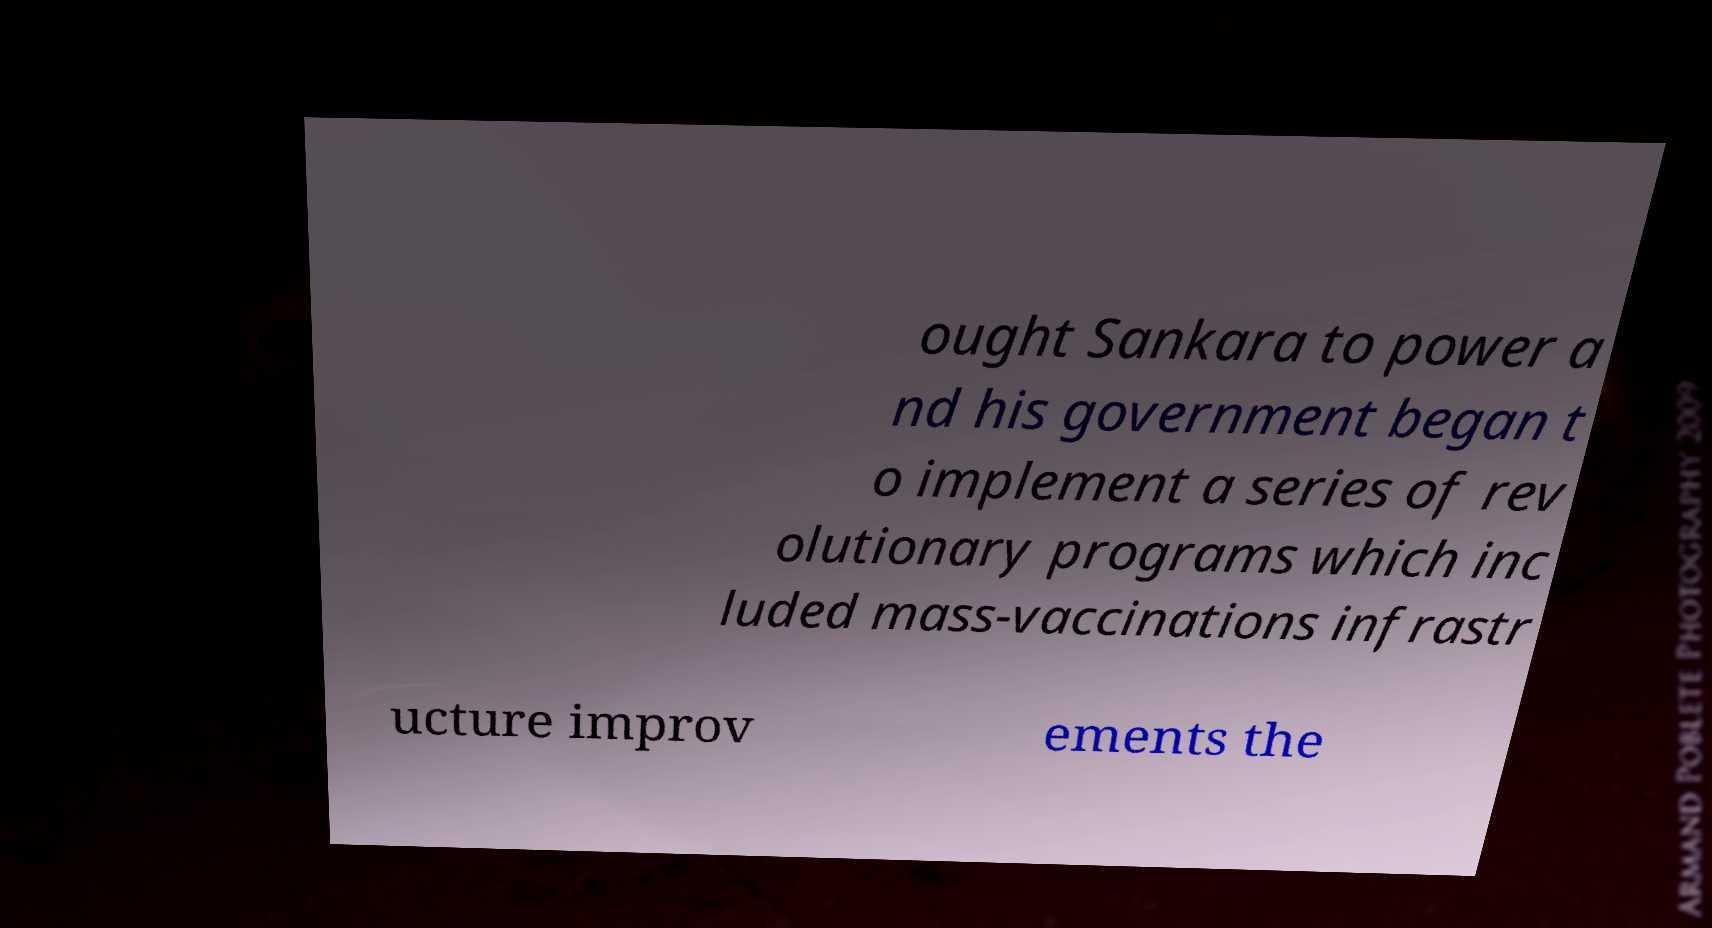Please identify and transcribe the text found in this image. ought Sankara to power a nd his government began t o implement a series of rev olutionary programs which inc luded mass-vaccinations infrastr ucture improv ements the 